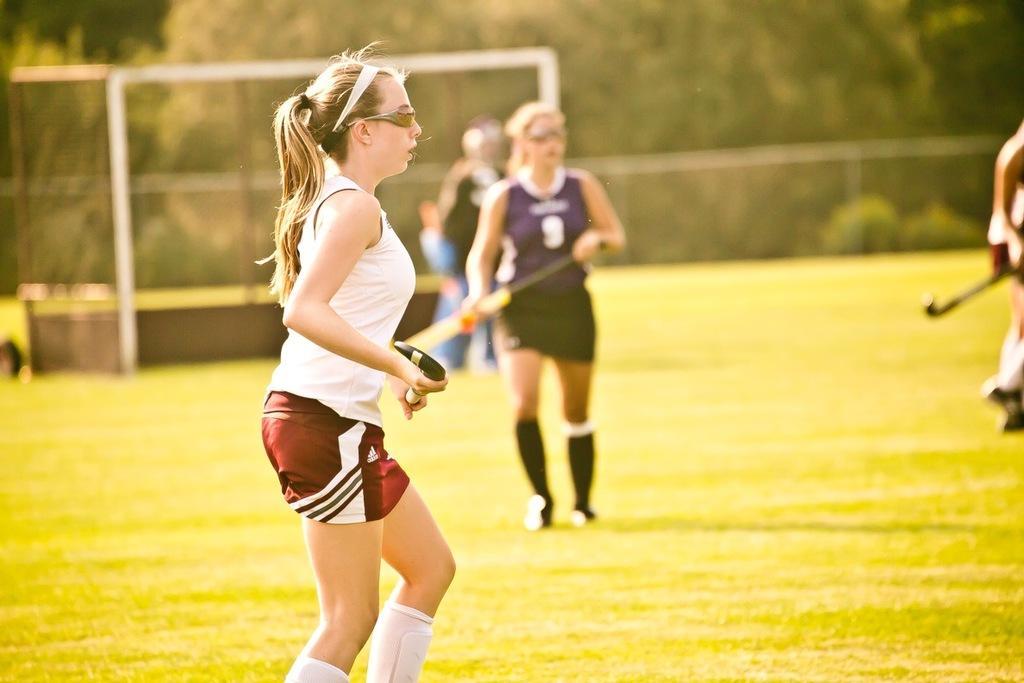Describe this image in one or two sentences. In this image we can see a group of people standing on the ground. One woman is wearing a white t shirt is holding a stick in her hands and wearing goggles. In the background, we can see a goal post, a group of trees. 